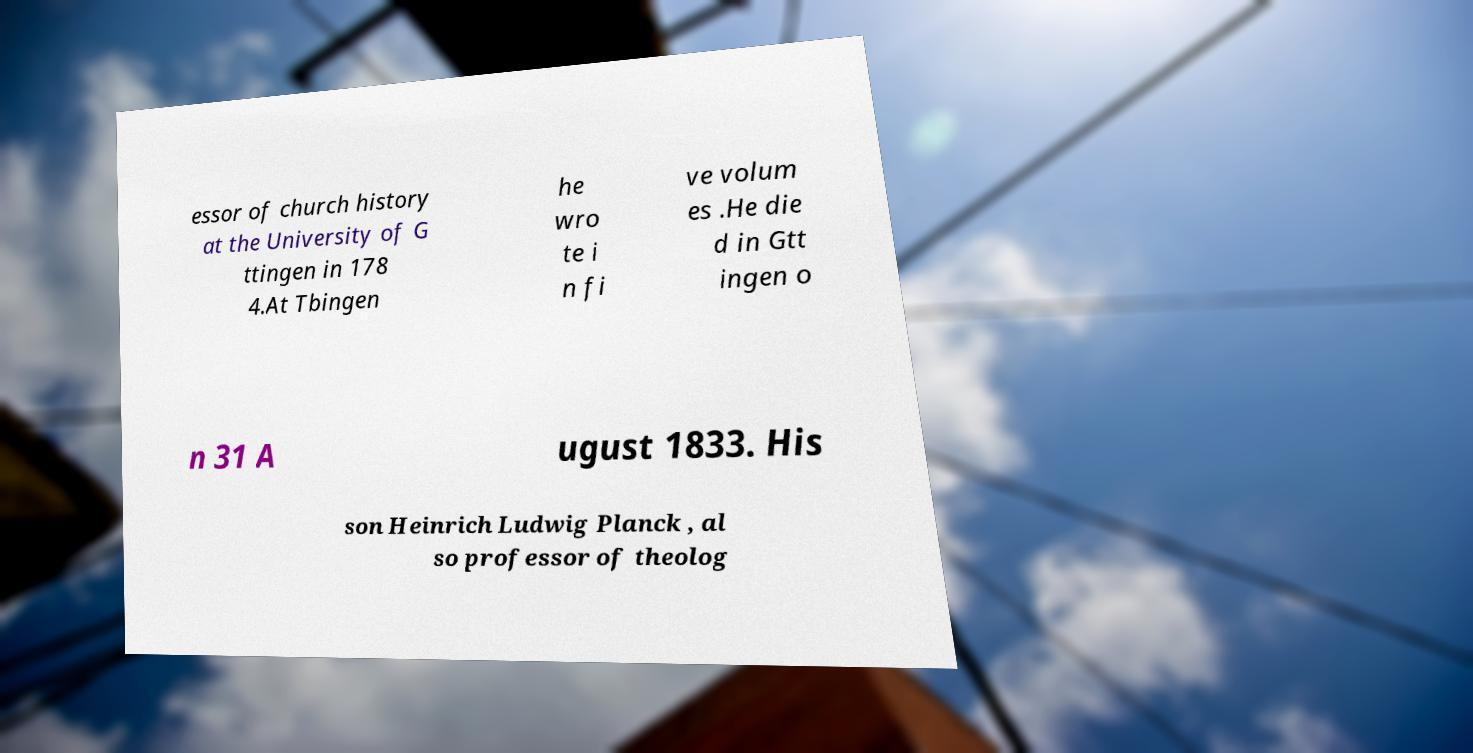Could you assist in decoding the text presented in this image and type it out clearly? essor of church history at the University of G ttingen in 178 4.At Tbingen he wro te i n fi ve volum es .He die d in Gtt ingen o n 31 A ugust 1833. His son Heinrich Ludwig Planck , al so professor of theolog 